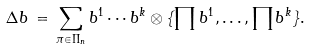<formula> <loc_0><loc_0><loc_500><loc_500>\Delta b \, = \, \sum _ { \pi \in \Pi _ { n } } b ^ { 1 } \cdots b ^ { k } \otimes \{ \prod b ^ { 1 } , \dots , \prod b ^ { k } \} .</formula> 